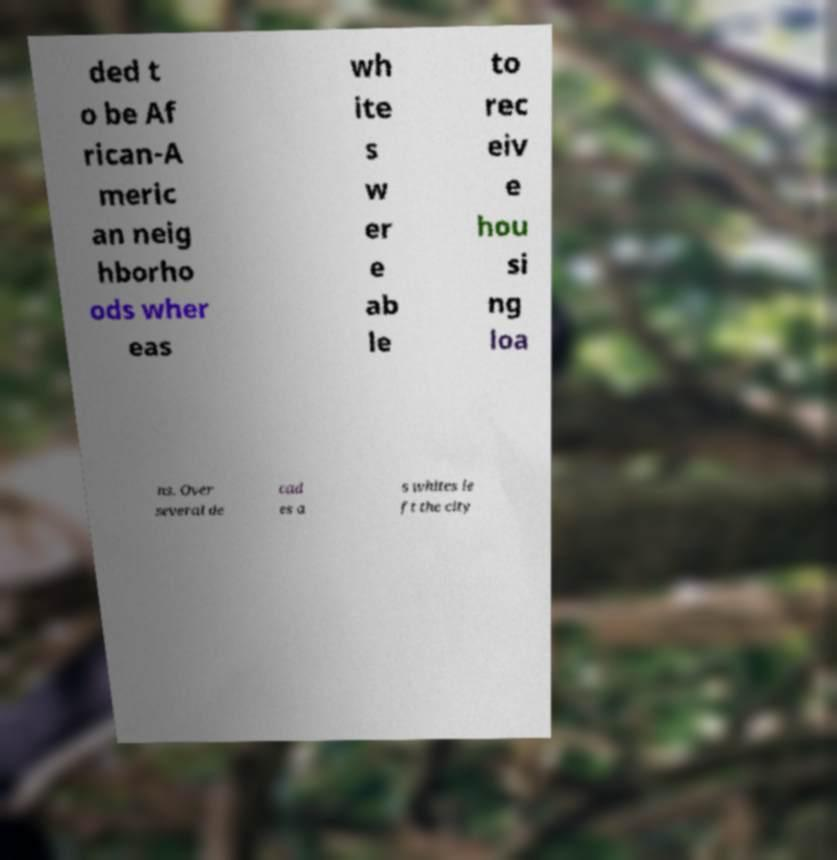Can you accurately transcribe the text from the provided image for me? ded t o be Af rican-A meric an neig hborho ods wher eas wh ite s w er e ab le to rec eiv e hou si ng loa ns. Over several de cad es a s whites le ft the city 